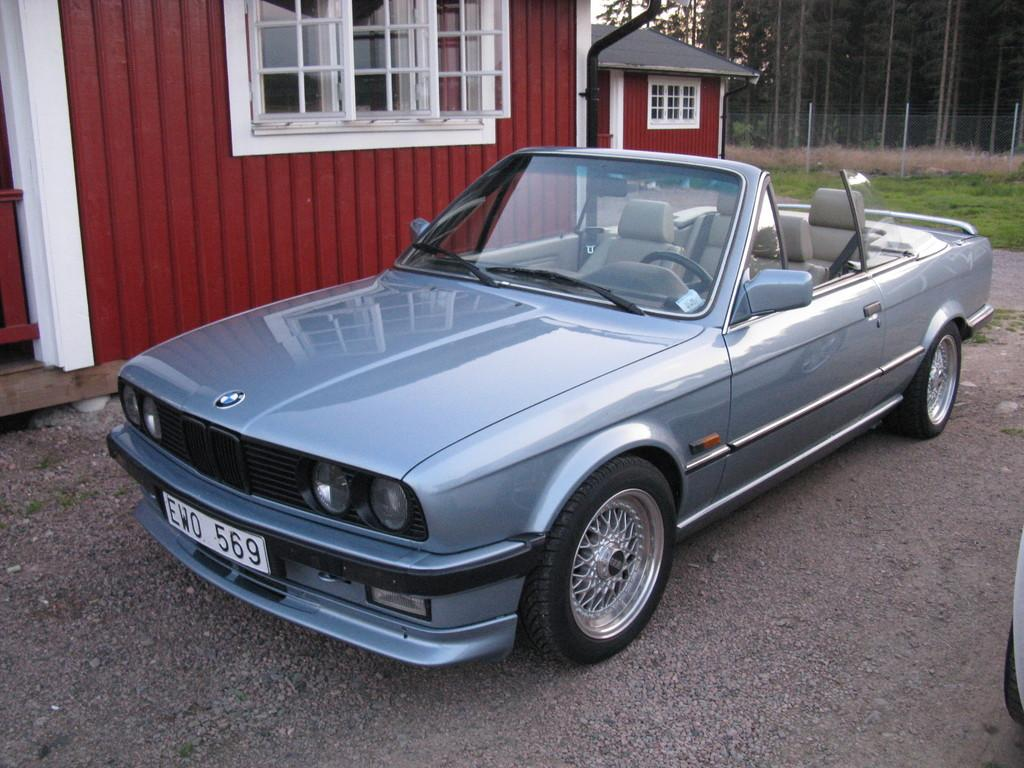What is the main subject in the foreground of the image? There is a car in the foreground of the image. What is the position of the car in relation to the ground? The car is on the ground. What structure can be seen behind the car? There is a house behind the car. What can be seen in the background of the image? There is fencing, grass, and trees in the background of the image. Who is the expert in the image? There is no expert present in the image; it features a car, a house, and elements in the background. What type of cannon can be seen in the image? There is no cannon present in the image. 